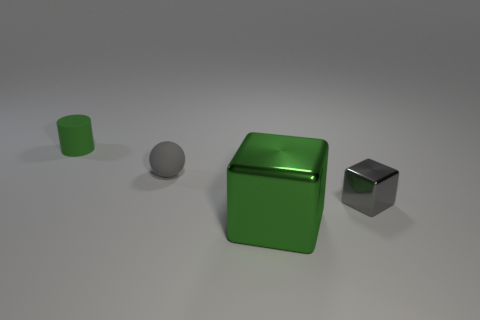There is a small object that is the same color as the tiny matte sphere; what shape is it?
Your answer should be compact. Cube. How many objects are large matte spheres or small gray things?
Your answer should be compact. 2. What is the color of the tiny object to the right of the big cube that is in front of the rubber thing to the left of the gray matte sphere?
Offer a terse response. Gray. Is there any other thing of the same color as the small rubber cylinder?
Offer a very short reply. Yes. Is the gray metal thing the same size as the rubber cylinder?
Your answer should be compact. Yes. What number of things are things in front of the small cube or small objects right of the small green rubber cylinder?
Provide a succinct answer. 3. There is a green thing that is to the right of the green object that is behind the green cube; what is it made of?
Keep it short and to the point. Metal. What number of other objects are there of the same material as the small green thing?
Provide a succinct answer. 1. Is the shape of the big green thing the same as the tiny gray rubber thing?
Your response must be concise. No. What is the size of the gray object on the right side of the small ball?
Keep it short and to the point. Small. 